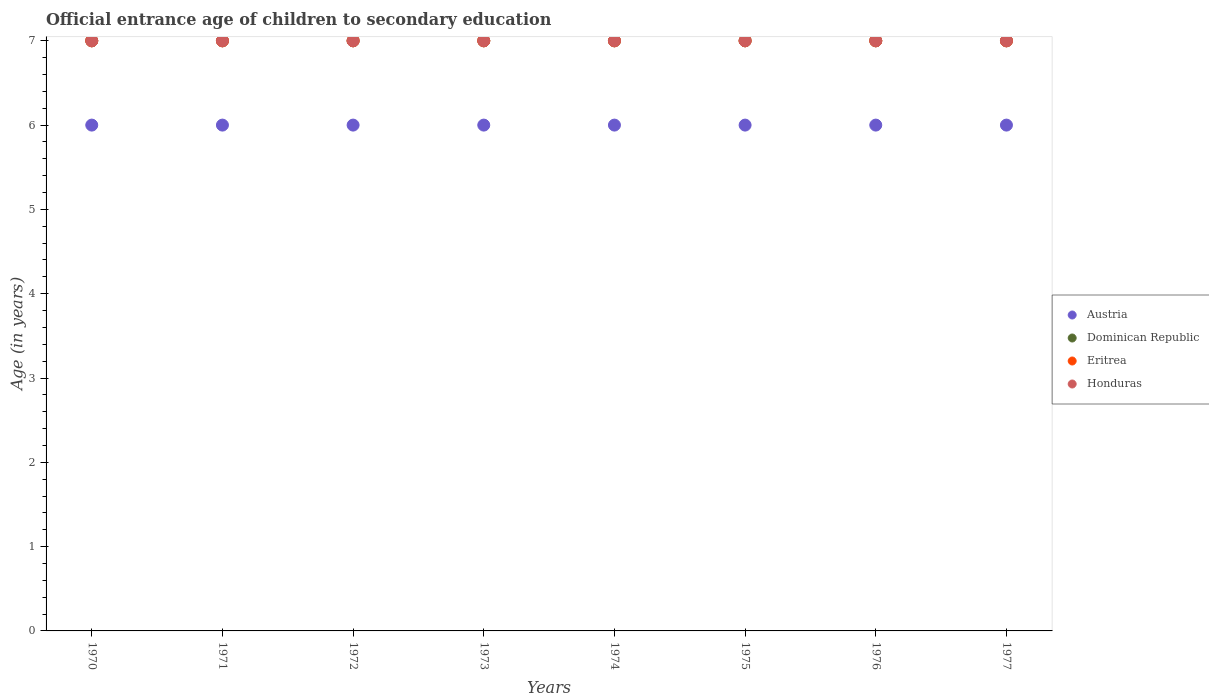What is the secondary school starting age of children in Dominican Republic in 1970?
Offer a terse response. 7. Across all years, what is the maximum secondary school starting age of children in Honduras?
Provide a succinct answer. 7. Across all years, what is the minimum secondary school starting age of children in Eritrea?
Your response must be concise. 7. In which year was the secondary school starting age of children in Honduras maximum?
Offer a very short reply. 1970. What is the total secondary school starting age of children in Austria in the graph?
Your answer should be compact. 48. What is the difference between the secondary school starting age of children in Honduras in 1973 and the secondary school starting age of children in Austria in 1974?
Your response must be concise. 1. Is the secondary school starting age of children in Dominican Republic in 1971 less than that in 1972?
Offer a terse response. No. Is the difference between the secondary school starting age of children in Eritrea in 1970 and 1973 greater than the difference between the secondary school starting age of children in Dominican Republic in 1970 and 1973?
Ensure brevity in your answer.  No. What is the difference between the highest and the second highest secondary school starting age of children in Dominican Republic?
Offer a terse response. 0. Is the sum of the secondary school starting age of children in Eritrea in 1975 and 1977 greater than the maximum secondary school starting age of children in Dominican Republic across all years?
Give a very brief answer. Yes. Is it the case that in every year, the sum of the secondary school starting age of children in Dominican Republic and secondary school starting age of children in Honduras  is greater than the secondary school starting age of children in Eritrea?
Offer a very short reply. Yes. Is the secondary school starting age of children in Dominican Republic strictly greater than the secondary school starting age of children in Eritrea over the years?
Keep it short and to the point. No. Are the values on the major ticks of Y-axis written in scientific E-notation?
Offer a very short reply. No. Does the graph contain any zero values?
Provide a short and direct response. No. How are the legend labels stacked?
Offer a terse response. Vertical. What is the title of the graph?
Ensure brevity in your answer.  Official entrance age of children to secondary education. Does "World" appear as one of the legend labels in the graph?
Your response must be concise. No. What is the label or title of the Y-axis?
Ensure brevity in your answer.  Age (in years). What is the Age (in years) in Eritrea in 1970?
Provide a short and direct response. 7. What is the Age (in years) in Honduras in 1970?
Offer a very short reply. 7. What is the Age (in years) of Dominican Republic in 1971?
Your response must be concise. 7. What is the Age (in years) of Eritrea in 1971?
Your response must be concise. 7. What is the Age (in years) of Austria in 1972?
Offer a terse response. 6. What is the Age (in years) in Eritrea in 1972?
Give a very brief answer. 7. What is the Age (in years) of Eritrea in 1974?
Give a very brief answer. 7. What is the Age (in years) in Honduras in 1974?
Your response must be concise. 7. What is the Age (in years) of Austria in 1975?
Provide a succinct answer. 6. What is the Age (in years) in Dominican Republic in 1975?
Give a very brief answer. 7. What is the Age (in years) of Austria in 1976?
Provide a short and direct response. 6. What is the Age (in years) in Dominican Republic in 1976?
Provide a succinct answer. 7. What is the Age (in years) in Eritrea in 1976?
Give a very brief answer. 7. What is the Age (in years) of Honduras in 1976?
Make the answer very short. 7. What is the Age (in years) in Austria in 1977?
Provide a succinct answer. 6. What is the Age (in years) in Eritrea in 1977?
Ensure brevity in your answer.  7. Across all years, what is the maximum Age (in years) of Dominican Republic?
Provide a succinct answer. 7. Across all years, what is the maximum Age (in years) in Honduras?
Provide a short and direct response. 7. Across all years, what is the minimum Age (in years) of Austria?
Offer a terse response. 6. Across all years, what is the minimum Age (in years) of Eritrea?
Your response must be concise. 7. Across all years, what is the minimum Age (in years) in Honduras?
Ensure brevity in your answer.  7. What is the difference between the Age (in years) in Austria in 1970 and that in 1971?
Offer a terse response. 0. What is the difference between the Age (in years) in Dominican Republic in 1970 and that in 1971?
Offer a terse response. 0. What is the difference between the Age (in years) in Eritrea in 1970 and that in 1971?
Provide a short and direct response. 0. What is the difference between the Age (in years) in Austria in 1970 and that in 1973?
Provide a short and direct response. 0. What is the difference between the Age (in years) of Dominican Republic in 1970 and that in 1973?
Provide a short and direct response. 0. What is the difference between the Age (in years) in Eritrea in 1970 and that in 1973?
Provide a succinct answer. 0. What is the difference between the Age (in years) of Honduras in 1970 and that in 1973?
Make the answer very short. 0. What is the difference between the Age (in years) in Honduras in 1970 and that in 1974?
Provide a succinct answer. 0. What is the difference between the Age (in years) of Dominican Republic in 1970 and that in 1975?
Make the answer very short. 0. What is the difference between the Age (in years) of Eritrea in 1970 and that in 1975?
Provide a succinct answer. 0. What is the difference between the Age (in years) in Honduras in 1970 and that in 1975?
Make the answer very short. 0. What is the difference between the Age (in years) of Austria in 1970 and that in 1976?
Your answer should be very brief. 0. What is the difference between the Age (in years) in Eritrea in 1970 and that in 1976?
Provide a short and direct response. 0. What is the difference between the Age (in years) in Honduras in 1970 and that in 1977?
Your response must be concise. 0. What is the difference between the Age (in years) in Austria in 1971 and that in 1973?
Keep it short and to the point. 0. What is the difference between the Age (in years) in Honduras in 1971 and that in 1973?
Keep it short and to the point. 0. What is the difference between the Age (in years) in Austria in 1971 and that in 1974?
Give a very brief answer. 0. What is the difference between the Age (in years) of Dominican Republic in 1971 and that in 1974?
Keep it short and to the point. 0. What is the difference between the Age (in years) in Eritrea in 1971 and that in 1974?
Offer a very short reply. 0. What is the difference between the Age (in years) of Honduras in 1971 and that in 1974?
Offer a terse response. 0. What is the difference between the Age (in years) in Dominican Republic in 1971 and that in 1975?
Provide a succinct answer. 0. What is the difference between the Age (in years) in Eritrea in 1971 and that in 1975?
Your answer should be very brief. 0. What is the difference between the Age (in years) in Honduras in 1971 and that in 1975?
Make the answer very short. 0. What is the difference between the Age (in years) of Austria in 1971 and that in 1976?
Provide a short and direct response. 0. What is the difference between the Age (in years) in Dominican Republic in 1971 and that in 1976?
Your answer should be compact. 0. What is the difference between the Age (in years) in Eritrea in 1971 and that in 1976?
Offer a terse response. 0. What is the difference between the Age (in years) of Honduras in 1971 and that in 1976?
Keep it short and to the point. 0. What is the difference between the Age (in years) of Austria in 1971 and that in 1977?
Give a very brief answer. 0. What is the difference between the Age (in years) in Eritrea in 1971 and that in 1977?
Give a very brief answer. 0. What is the difference between the Age (in years) of Dominican Republic in 1972 and that in 1974?
Your answer should be very brief. 0. What is the difference between the Age (in years) in Eritrea in 1972 and that in 1974?
Offer a terse response. 0. What is the difference between the Age (in years) in Honduras in 1972 and that in 1974?
Provide a succinct answer. 0. What is the difference between the Age (in years) of Dominican Republic in 1972 and that in 1975?
Offer a terse response. 0. What is the difference between the Age (in years) of Eritrea in 1972 and that in 1975?
Your answer should be very brief. 0. What is the difference between the Age (in years) in Austria in 1972 and that in 1977?
Offer a terse response. 0. What is the difference between the Age (in years) of Dominican Republic in 1972 and that in 1977?
Provide a succinct answer. 0. What is the difference between the Age (in years) of Eritrea in 1972 and that in 1977?
Offer a terse response. 0. What is the difference between the Age (in years) of Honduras in 1972 and that in 1977?
Your answer should be compact. 0. What is the difference between the Age (in years) of Austria in 1973 and that in 1974?
Keep it short and to the point. 0. What is the difference between the Age (in years) in Eritrea in 1973 and that in 1974?
Your answer should be compact. 0. What is the difference between the Age (in years) in Honduras in 1973 and that in 1975?
Your answer should be very brief. 0. What is the difference between the Age (in years) in Honduras in 1973 and that in 1976?
Provide a short and direct response. 0. What is the difference between the Age (in years) of Dominican Republic in 1973 and that in 1977?
Your response must be concise. 0. What is the difference between the Age (in years) of Austria in 1974 and that in 1975?
Offer a very short reply. 0. What is the difference between the Age (in years) in Eritrea in 1974 and that in 1975?
Offer a very short reply. 0. What is the difference between the Age (in years) of Austria in 1974 and that in 1976?
Your answer should be compact. 0. What is the difference between the Age (in years) of Eritrea in 1974 and that in 1976?
Keep it short and to the point. 0. What is the difference between the Age (in years) in Eritrea in 1974 and that in 1977?
Your answer should be compact. 0. What is the difference between the Age (in years) in Honduras in 1974 and that in 1977?
Your answer should be very brief. 0. What is the difference between the Age (in years) in Dominican Republic in 1975 and that in 1976?
Keep it short and to the point. 0. What is the difference between the Age (in years) of Honduras in 1975 and that in 1976?
Your answer should be compact. 0. What is the difference between the Age (in years) of Dominican Republic in 1975 and that in 1977?
Offer a very short reply. 0. What is the difference between the Age (in years) of Dominican Republic in 1976 and that in 1977?
Offer a terse response. 0. What is the difference between the Age (in years) in Austria in 1970 and the Age (in years) in Eritrea in 1971?
Your answer should be compact. -1. What is the difference between the Age (in years) of Austria in 1970 and the Age (in years) of Honduras in 1971?
Your response must be concise. -1. What is the difference between the Age (in years) in Dominican Republic in 1970 and the Age (in years) in Eritrea in 1971?
Your answer should be very brief. 0. What is the difference between the Age (in years) in Eritrea in 1970 and the Age (in years) in Honduras in 1971?
Provide a short and direct response. 0. What is the difference between the Age (in years) in Austria in 1970 and the Age (in years) in Dominican Republic in 1972?
Provide a short and direct response. -1. What is the difference between the Age (in years) in Austria in 1970 and the Age (in years) in Honduras in 1972?
Your answer should be compact. -1. What is the difference between the Age (in years) in Eritrea in 1970 and the Age (in years) in Honduras in 1972?
Your response must be concise. 0. What is the difference between the Age (in years) in Austria in 1970 and the Age (in years) in Dominican Republic in 1973?
Your response must be concise. -1. What is the difference between the Age (in years) in Eritrea in 1970 and the Age (in years) in Honduras in 1973?
Give a very brief answer. 0. What is the difference between the Age (in years) of Austria in 1970 and the Age (in years) of Eritrea in 1974?
Offer a very short reply. -1. What is the difference between the Age (in years) in Austria in 1970 and the Age (in years) in Honduras in 1974?
Ensure brevity in your answer.  -1. What is the difference between the Age (in years) of Dominican Republic in 1970 and the Age (in years) of Eritrea in 1974?
Provide a short and direct response. 0. What is the difference between the Age (in years) in Eritrea in 1970 and the Age (in years) in Honduras in 1974?
Ensure brevity in your answer.  0. What is the difference between the Age (in years) of Austria in 1970 and the Age (in years) of Dominican Republic in 1975?
Give a very brief answer. -1. What is the difference between the Age (in years) of Austria in 1970 and the Age (in years) of Honduras in 1975?
Offer a terse response. -1. What is the difference between the Age (in years) in Dominican Republic in 1970 and the Age (in years) in Honduras in 1975?
Offer a very short reply. 0. What is the difference between the Age (in years) of Austria in 1970 and the Age (in years) of Dominican Republic in 1976?
Provide a succinct answer. -1. What is the difference between the Age (in years) in Austria in 1970 and the Age (in years) in Honduras in 1976?
Your answer should be compact. -1. What is the difference between the Age (in years) of Dominican Republic in 1970 and the Age (in years) of Honduras in 1976?
Your answer should be compact. 0. What is the difference between the Age (in years) in Austria in 1970 and the Age (in years) in Dominican Republic in 1977?
Your answer should be compact. -1. What is the difference between the Age (in years) of Austria in 1970 and the Age (in years) of Eritrea in 1977?
Offer a terse response. -1. What is the difference between the Age (in years) of Austria in 1970 and the Age (in years) of Honduras in 1977?
Provide a short and direct response. -1. What is the difference between the Age (in years) in Dominican Republic in 1970 and the Age (in years) in Eritrea in 1977?
Give a very brief answer. 0. What is the difference between the Age (in years) in Dominican Republic in 1970 and the Age (in years) in Honduras in 1977?
Offer a terse response. 0. What is the difference between the Age (in years) in Austria in 1971 and the Age (in years) in Dominican Republic in 1972?
Give a very brief answer. -1. What is the difference between the Age (in years) of Austria in 1971 and the Age (in years) of Eritrea in 1972?
Your answer should be compact. -1. What is the difference between the Age (in years) in Dominican Republic in 1971 and the Age (in years) in Eritrea in 1972?
Offer a very short reply. 0. What is the difference between the Age (in years) in Eritrea in 1971 and the Age (in years) in Honduras in 1972?
Give a very brief answer. 0. What is the difference between the Age (in years) in Austria in 1971 and the Age (in years) in Eritrea in 1973?
Ensure brevity in your answer.  -1. What is the difference between the Age (in years) of Dominican Republic in 1971 and the Age (in years) of Eritrea in 1973?
Your answer should be compact. 0. What is the difference between the Age (in years) in Austria in 1971 and the Age (in years) in Dominican Republic in 1974?
Give a very brief answer. -1. What is the difference between the Age (in years) in Austria in 1971 and the Age (in years) in Eritrea in 1974?
Give a very brief answer. -1. What is the difference between the Age (in years) in Dominican Republic in 1971 and the Age (in years) in Eritrea in 1974?
Provide a succinct answer. 0. What is the difference between the Age (in years) of Dominican Republic in 1971 and the Age (in years) of Honduras in 1974?
Your response must be concise. 0. What is the difference between the Age (in years) of Austria in 1971 and the Age (in years) of Eritrea in 1975?
Keep it short and to the point. -1. What is the difference between the Age (in years) in Eritrea in 1971 and the Age (in years) in Honduras in 1975?
Ensure brevity in your answer.  0. What is the difference between the Age (in years) in Austria in 1971 and the Age (in years) in Eritrea in 1976?
Your answer should be very brief. -1. What is the difference between the Age (in years) of Austria in 1971 and the Age (in years) of Honduras in 1976?
Provide a succinct answer. -1. What is the difference between the Age (in years) in Eritrea in 1971 and the Age (in years) in Honduras in 1976?
Your response must be concise. 0. What is the difference between the Age (in years) in Austria in 1971 and the Age (in years) in Dominican Republic in 1977?
Keep it short and to the point. -1. What is the difference between the Age (in years) of Austria in 1971 and the Age (in years) of Honduras in 1977?
Provide a succinct answer. -1. What is the difference between the Age (in years) of Eritrea in 1971 and the Age (in years) of Honduras in 1977?
Ensure brevity in your answer.  0. What is the difference between the Age (in years) of Austria in 1972 and the Age (in years) of Honduras in 1973?
Your answer should be compact. -1. What is the difference between the Age (in years) in Dominican Republic in 1972 and the Age (in years) in Eritrea in 1973?
Provide a short and direct response. 0. What is the difference between the Age (in years) in Dominican Republic in 1972 and the Age (in years) in Honduras in 1973?
Provide a succinct answer. 0. What is the difference between the Age (in years) of Austria in 1972 and the Age (in years) of Dominican Republic in 1974?
Offer a very short reply. -1. What is the difference between the Age (in years) of Austria in 1972 and the Age (in years) of Eritrea in 1974?
Your response must be concise. -1. What is the difference between the Age (in years) of Austria in 1972 and the Age (in years) of Honduras in 1974?
Make the answer very short. -1. What is the difference between the Age (in years) of Austria in 1972 and the Age (in years) of Dominican Republic in 1975?
Offer a terse response. -1. What is the difference between the Age (in years) of Dominican Republic in 1972 and the Age (in years) of Eritrea in 1975?
Offer a very short reply. 0. What is the difference between the Age (in years) in Dominican Republic in 1972 and the Age (in years) in Honduras in 1975?
Make the answer very short. 0. What is the difference between the Age (in years) in Eritrea in 1972 and the Age (in years) in Honduras in 1975?
Offer a very short reply. 0. What is the difference between the Age (in years) of Austria in 1972 and the Age (in years) of Dominican Republic in 1976?
Give a very brief answer. -1. What is the difference between the Age (in years) of Austria in 1972 and the Age (in years) of Eritrea in 1976?
Your answer should be compact. -1. What is the difference between the Age (in years) in Austria in 1972 and the Age (in years) in Dominican Republic in 1977?
Your response must be concise. -1. What is the difference between the Age (in years) of Austria in 1972 and the Age (in years) of Honduras in 1977?
Offer a terse response. -1. What is the difference between the Age (in years) of Dominican Republic in 1972 and the Age (in years) of Eritrea in 1977?
Ensure brevity in your answer.  0. What is the difference between the Age (in years) of Dominican Republic in 1972 and the Age (in years) of Honduras in 1977?
Your answer should be compact. 0. What is the difference between the Age (in years) in Eritrea in 1972 and the Age (in years) in Honduras in 1977?
Offer a terse response. 0. What is the difference between the Age (in years) of Austria in 1973 and the Age (in years) of Eritrea in 1974?
Offer a very short reply. -1. What is the difference between the Age (in years) of Dominican Republic in 1973 and the Age (in years) of Honduras in 1974?
Provide a short and direct response. 0. What is the difference between the Age (in years) of Eritrea in 1973 and the Age (in years) of Honduras in 1974?
Provide a succinct answer. 0. What is the difference between the Age (in years) in Austria in 1973 and the Age (in years) in Dominican Republic in 1975?
Offer a terse response. -1. What is the difference between the Age (in years) of Austria in 1973 and the Age (in years) of Honduras in 1975?
Provide a succinct answer. -1. What is the difference between the Age (in years) of Dominican Republic in 1973 and the Age (in years) of Eritrea in 1975?
Give a very brief answer. 0. What is the difference between the Age (in years) of Dominican Republic in 1973 and the Age (in years) of Honduras in 1975?
Provide a succinct answer. 0. What is the difference between the Age (in years) of Austria in 1973 and the Age (in years) of Eritrea in 1976?
Your answer should be very brief. -1. What is the difference between the Age (in years) in Austria in 1973 and the Age (in years) in Dominican Republic in 1977?
Provide a succinct answer. -1. What is the difference between the Age (in years) of Austria in 1973 and the Age (in years) of Eritrea in 1977?
Provide a short and direct response. -1. What is the difference between the Age (in years) of Austria in 1973 and the Age (in years) of Honduras in 1977?
Ensure brevity in your answer.  -1. What is the difference between the Age (in years) of Dominican Republic in 1973 and the Age (in years) of Eritrea in 1977?
Keep it short and to the point. 0. What is the difference between the Age (in years) in Eritrea in 1973 and the Age (in years) in Honduras in 1977?
Keep it short and to the point. 0. What is the difference between the Age (in years) in Austria in 1974 and the Age (in years) in Honduras in 1975?
Give a very brief answer. -1. What is the difference between the Age (in years) of Austria in 1974 and the Age (in years) of Honduras in 1976?
Keep it short and to the point. -1. What is the difference between the Age (in years) in Dominican Republic in 1974 and the Age (in years) in Eritrea in 1976?
Keep it short and to the point. 0. What is the difference between the Age (in years) in Dominican Republic in 1974 and the Age (in years) in Honduras in 1976?
Keep it short and to the point. 0. What is the difference between the Age (in years) of Eritrea in 1974 and the Age (in years) of Honduras in 1976?
Offer a very short reply. 0. What is the difference between the Age (in years) in Dominican Republic in 1974 and the Age (in years) in Eritrea in 1977?
Give a very brief answer. 0. What is the difference between the Age (in years) in Dominican Republic in 1974 and the Age (in years) in Honduras in 1977?
Your answer should be compact. 0. What is the difference between the Age (in years) in Austria in 1975 and the Age (in years) in Eritrea in 1976?
Your response must be concise. -1. What is the difference between the Age (in years) of Dominican Republic in 1975 and the Age (in years) of Eritrea in 1976?
Ensure brevity in your answer.  0. What is the difference between the Age (in years) in Dominican Republic in 1975 and the Age (in years) in Honduras in 1976?
Offer a terse response. 0. What is the difference between the Age (in years) in Eritrea in 1975 and the Age (in years) in Honduras in 1976?
Your answer should be compact. 0. What is the difference between the Age (in years) of Austria in 1975 and the Age (in years) of Dominican Republic in 1977?
Make the answer very short. -1. What is the difference between the Age (in years) of Austria in 1975 and the Age (in years) of Honduras in 1977?
Provide a short and direct response. -1. What is the difference between the Age (in years) in Dominican Republic in 1975 and the Age (in years) in Eritrea in 1977?
Give a very brief answer. 0. What is the difference between the Age (in years) in Eritrea in 1975 and the Age (in years) in Honduras in 1977?
Your answer should be very brief. 0. What is the difference between the Age (in years) of Austria in 1976 and the Age (in years) of Eritrea in 1977?
Provide a succinct answer. -1. What is the difference between the Age (in years) in Dominican Republic in 1976 and the Age (in years) in Eritrea in 1977?
Your response must be concise. 0. What is the difference between the Age (in years) of Dominican Republic in 1976 and the Age (in years) of Honduras in 1977?
Offer a very short reply. 0. What is the difference between the Age (in years) in Eritrea in 1976 and the Age (in years) in Honduras in 1977?
Give a very brief answer. 0. What is the average Age (in years) of Austria per year?
Your answer should be very brief. 6. What is the average Age (in years) of Dominican Republic per year?
Your answer should be compact. 7. In the year 1970, what is the difference between the Age (in years) in Dominican Republic and Age (in years) in Honduras?
Your answer should be compact. 0. In the year 1971, what is the difference between the Age (in years) in Austria and Age (in years) in Dominican Republic?
Provide a succinct answer. -1. In the year 1971, what is the difference between the Age (in years) of Austria and Age (in years) of Eritrea?
Offer a terse response. -1. In the year 1972, what is the difference between the Age (in years) of Austria and Age (in years) of Eritrea?
Your answer should be compact. -1. In the year 1972, what is the difference between the Age (in years) of Austria and Age (in years) of Honduras?
Offer a terse response. -1. In the year 1972, what is the difference between the Age (in years) of Dominican Republic and Age (in years) of Honduras?
Offer a terse response. 0. In the year 1973, what is the difference between the Age (in years) in Austria and Age (in years) in Dominican Republic?
Your answer should be very brief. -1. In the year 1973, what is the difference between the Age (in years) in Austria and Age (in years) in Eritrea?
Your response must be concise. -1. In the year 1973, what is the difference between the Age (in years) of Austria and Age (in years) of Honduras?
Give a very brief answer. -1. In the year 1973, what is the difference between the Age (in years) in Dominican Republic and Age (in years) in Eritrea?
Provide a short and direct response. 0. In the year 1973, what is the difference between the Age (in years) in Dominican Republic and Age (in years) in Honduras?
Make the answer very short. 0. In the year 1974, what is the difference between the Age (in years) of Austria and Age (in years) of Dominican Republic?
Offer a very short reply. -1. In the year 1974, what is the difference between the Age (in years) of Austria and Age (in years) of Eritrea?
Offer a very short reply. -1. In the year 1974, what is the difference between the Age (in years) in Austria and Age (in years) in Honduras?
Provide a short and direct response. -1. In the year 1974, what is the difference between the Age (in years) of Dominican Republic and Age (in years) of Eritrea?
Your answer should be very brief. 0. In the year 1975, what is the difference between the Age (in years) in Austria and Age (in years) in Dominican Republic?
Give a very brief answer. -1. In the year 1975, what is the difference between the Age (in years) in Austria and Age (in years) in Eritrea?
Offer a terse response. -1. In the year 1975, what is the difference between the Age (in years) of Dominican Republic and Age (in years) of Eritrea?
Provide a short and direct response. 0. In the year 1975, what is the difference between the Age (in years) in Eritrea and Age (in years) in Honduras?
Provide a succinct answer. 0. In the year 1976, what is the difference between the Age (in years) in Austria and Age (in years) in Dominican Republic?
Your answer should be compact. -1. In the year 1976, what is the difference between the Age (in years) in Austria and Age (in years) in Eritrea?
Keep it short and to the point. -1. In the year 1976, what is the difference between the Age (in years) of Austria and Age (in years) of Honduras?
Offer a terse response. -1. In the year 1976, what is the difference between the Age (in years) of Dominican Republic and Age (in years) of Honduras?
Keep it short and to the point. 0. In the year 1976, what is the difference between the Age (in years) in Eritrea and Age (in years) in Honduras?
Give a very brief answer. 0. In the year 1977, what is the difference between the Age (in years) of Austria and Age (in years) of Dominican Republic?
Offer a very short reply. -1. In the year 1977, what is the difference between the Age (in years) of Austria and Age (in years) of Honduras?
Ensure brevity in your answer.  -1. What is the ratio of the Age (in years) of Austria in 1970 to that in 1971?
Make the answer very short. 1. What is the ratio of the Age (in years) in Eritrea in 1970 to that in 1971?
Make the answer very short. 1. What is the ratio of the Age (in years) in Honduras in 1970 to that in 1971?
Keep it short and to the point. 1. What is the ratio of the Age (in years) in Dominican Republic in 1970 to that in 1972?
Keep it short and to the point. 1. What is the ratio of the Age (in years) of Eritrea in 1970 to that in 1972?
Your response must be concise. 1. What is the ratio of the Age (in years) of Austria in 1970 to that in 1973?
Your answer should be compact. 1. What is the ratio of the Age (in years) of Dominican Republic in 1970 to that in 1973?
Your response must be concise. 1. What is the ratio of the Age (in years) of Eritrea in 1970 to that in 1973?
Offer a very short reply. 1. What is the ratio of the Age (in years) of Austria in 1970 to that in 1974?
Your answer should be very brief. 1. What is the ratio of the Age (in years) of Dominican Republic in 1970 to that in 1975?
Provide a short and direct response. 1. What is the ratio of the Age (in years) of Austria in 1970 to that in 1976?
Keep it short and to the point. 1. What is the ratio of the Age (in years) in Dominican Republic in 1970 to that in 1976?
Your response must be concise. 1. What is the ratio of the Age (in years) in Eritrea in 1970 to that in 1976?
Provide a succinct answer. 1. What is the ratio of the Age (in years) of Dominican Republic in 1970 to that in 1977?
Your answer should be very brief. 1. What is the ratio of the Age (in years) of Austria in 1971 to that in 1972?
Keep it short and to the point. 1. What is the ratio of the Age (in years) of Dominican Republic in 1971 to that in 1972?
Your response must be concise. 1. What is the ratio of the Age (in years) in Eritrea in 1971 to that in 1972?
Ensure brevity in your answer.  1. What is the ratio of the Age (in years) of Honduras in 1971 to that in 1972?
Offer a very short reply. 1. What is the ratio of the Age (in years) of Austria in 1971 to that in 1973?
Your answer should be compact. 1. What is the ratio of the Age (in years) in Eritrea in 1971 to that in 1973?
Make the answer very short. 1. What is the ratio of the Age (in years) in Honduras in 1971 to that in 1973?
Give a very brief answer. 1. What is the ratio of the Age (in years) of Austria in 1971 to that in 1974?
Ensure brevity in your answer.  1. What is the ratio of the Age (in years) in Eritrea in 1971 to that in 1974?
Ensure brevity in your answer.  1. What is the ratio of the Age (in years) of Austria in 1971 to that in 1975?
Offer a very short reply. 1. What is the ratio of the Age (in years) of Dominican Republic in 1971 to that in 1975?
Your answer should be compact. 1. What is the ratio of the Age (in years) of Dominican Republic in 1971 to that in 1976?
Provide a short and direct response. 1. What is the ratio of the Age (in years) in Austria in 1971 to that in 1977?
Offer a very short reply. 1. What is the ratio of the Age (in years) in Eritrea in 1971 to that in 1977?
Ensure brevity in your answer.  1. What is the ratio of the Age (in years) of Eritrea in 1972 to that in 1973?
Provide a succinct answer. 1. What is the ratio of the Age (in years) of Austria in 1972 to that in 1974?
Your answer should be compact. 1. What is the ratio of the Age (in years) in Eritrea in 1972 to that in 1974?
Offer a very short reply. 1. What is the ratio of the Age (in years) in Honduras in 1972 to that in 1974?
Keep it short and to the point. 1. What is the ratio of the Age (in years) of Austria in 1972 to that in 1975?
Offer a very short reply. 1. What is the ratio of the Age (in years) in Dominican Republic in 1972 to that in 1975?
Ensure brevity in your answer.  1. What is the ratio of the Age (in years) of Honduras in 1972 to that in 1975?
Your answer should be compact. 1. What is the ratio of the Age (in years) of Austria in 1972 to that in 1976?
Make the answer very short. 1. What is the ratio of the Age (in years) in Austria in 1972 to that in 1977?
Offer a very short reply. 1. What is the ratio of the Age (in years) of Dominican Republic in 1972 to that in 1977?
Provide a succinct answer. 1. What is the ratio of the Age (in years) of Eritrea in 1972 to that in 1977?
Offer a very short reply. 1. What is the ratio of the Age (in years) in Austria in 1973 to that in 1974?
Your answer should be compact. 1. What is the ratio of the Age (in years) in Dominican Republic in 1973 to that in 1974?
Your answer should be very brief. 1. What is the ratio of the Age (in years) in Eritrea in 1973 to that in 1974?
Give a very brief answer. 1. What is the ratio of the Age (in years) of Honduras in 1973 to that in 1974?
Offer a terse response. 1. What is the ratio of the Age (in years) in Dominican Republic in 1973 to that in 1975?
Provide a short and direct response. 1. What is the ratio of the Age (in years) of Eritrea in 1973 to that in 1975?
Provide a short and direct response. 1. What is the ratio of the Age (in years) of Honduras in 1973 to that in 1975?
Ensure brevity in your answer.  1. What is the ratio of the Age (in years) in Austria in 1973 to that in 1976?
Offer a very short reply. 1. What is the ratio of the Age (in years) in Dominican Republic in 1973 to that in 1976?
Provide a short and direct response. 1. What is the ratio of the Age (in years) of Eritrea in 1973 to that in 1976?
Your response must be concise. 1. What is the ratio of the Age (in years) of Eritrea in 1973 to that in 1977?
Provide a short and direct response. 1. What is the ratio of the Age (in years) in Austria in 1974 to that in 1975?
Give a very brief answer. 1. What is the ratio of the Age (in years) in Austria in 1974 to that in 1976?
Offer a terse response. 1. What is the ratio of the Age (in years) in Dominican Republic in 1974 to that in 1976?
Ensure brevity in your answer.  1. What is the ratio of the Age (in years) of Austria in 1974 to that in 1977?
Offer a very short reply. 1. What is the ratio of the Age (in years) of Dominican Republic in 1974 to that in 1977?
Provide a succinct answer. 1. What is the ratio of the Age (in years) of Honduras in 1975 to that in 1976?
Give a very brief answer. 1. What is the ratio of the Age (in years) of Dominican Republic in 1976 to that in 1977?
Make the answer very short. 1. What is the ratio of the Age (in years) in Eritrea in 1976 to that in 1977?
Keep it short and to the point. 1. What is the difference between the highest and the second highest Age (in years) of Honduras?
Give a very brief answer. 0. What is the difference between the highest and the lowest Age (in years) in Dominican Republic?
Offer a very short reply. 0. What is the difference between the highest and the lowest Age (in years) of Eritrea?
Give a very brief answer. 0. 